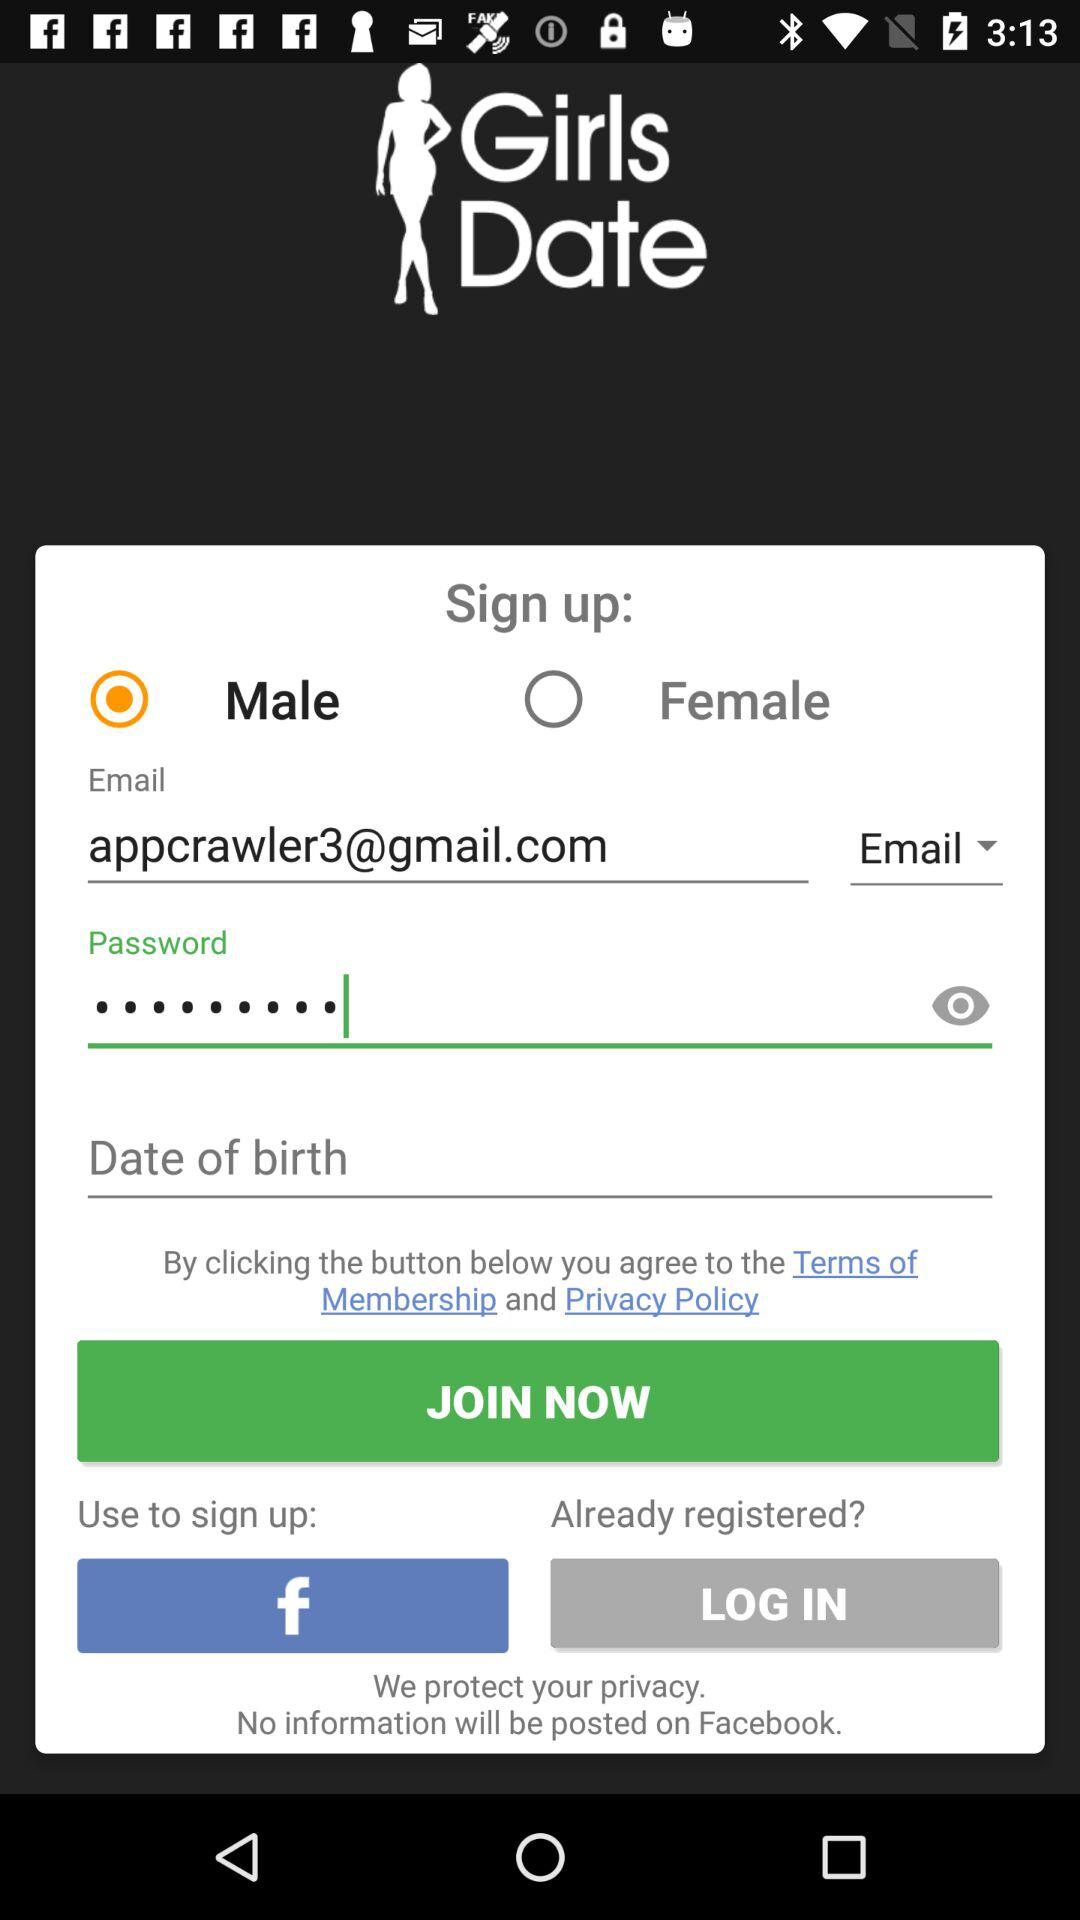What application can be used for sign up? The application is "Facebook". 